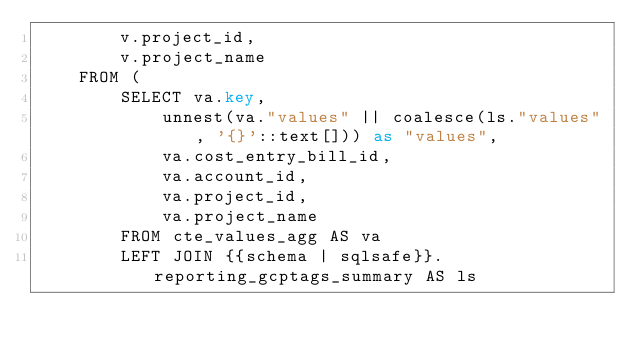<code> <loc_0><loc_0><loc_500><loc_500><_SQL_>        v.project_id,
        v.project_name
    FROM (
        SELECT va.key,
            unnest(va."values" || coalesce(ls."values", '{}'::text[])) as "values",
            va.cost_entry_bill_id,
            va.account_id,
            va.project_id,
            va.project_name
        FROM cte_values_agg AS va
        LEFT JOIN {{schema | sqlsafe}}.reporting_gcptags_summary AS ls</code> 